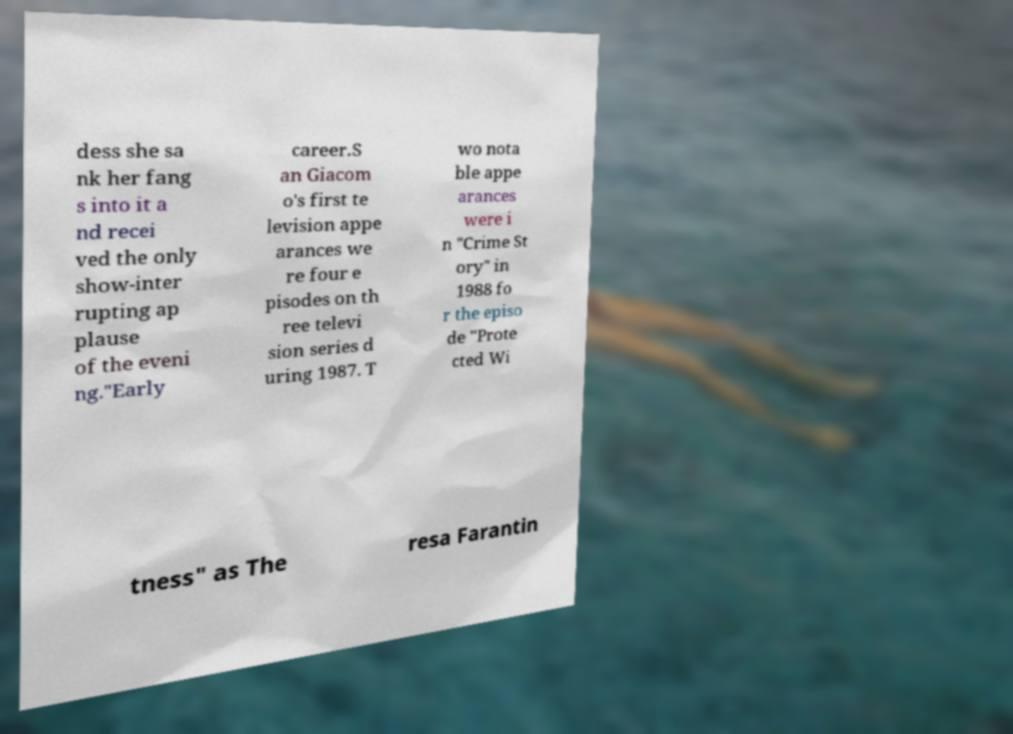Can you accurately transcribe the text from the provided image for me? dess she sa nk her fang s into it a nd recei ved the only show-inter rupting ap plause of the eveni ng."Early career.S an Giacom o's first te levision appe arances we re four e pisodes on th ree televi sion series d uring 1987. T wo nota ble appe arances were i n "Crime St ory" in 1988 fo r the episo de "Prote cted Wi tness" as The resa Farantin 